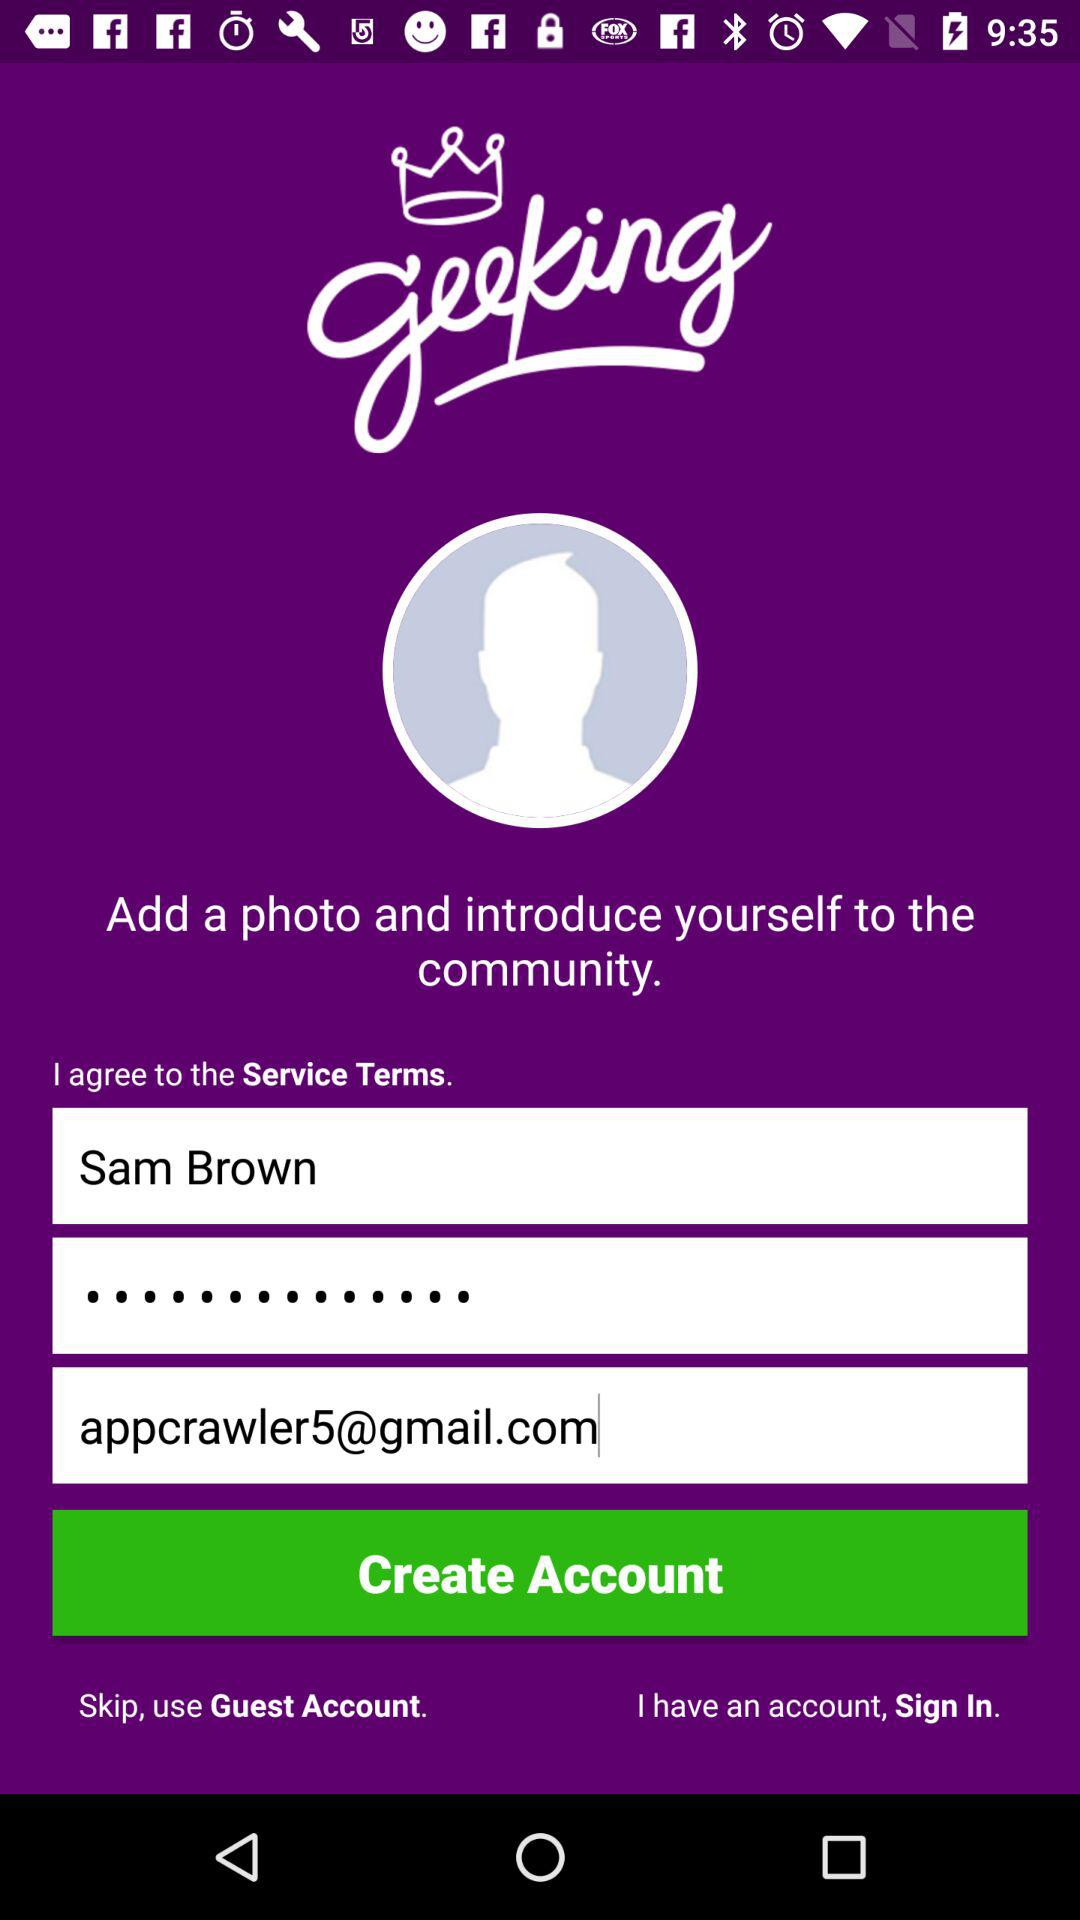What is the name of the application? The name of the application is "geeking". 